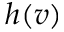<formula> <loc_0><loc_0><loc_500><loc_500>h ( v )</formula> 